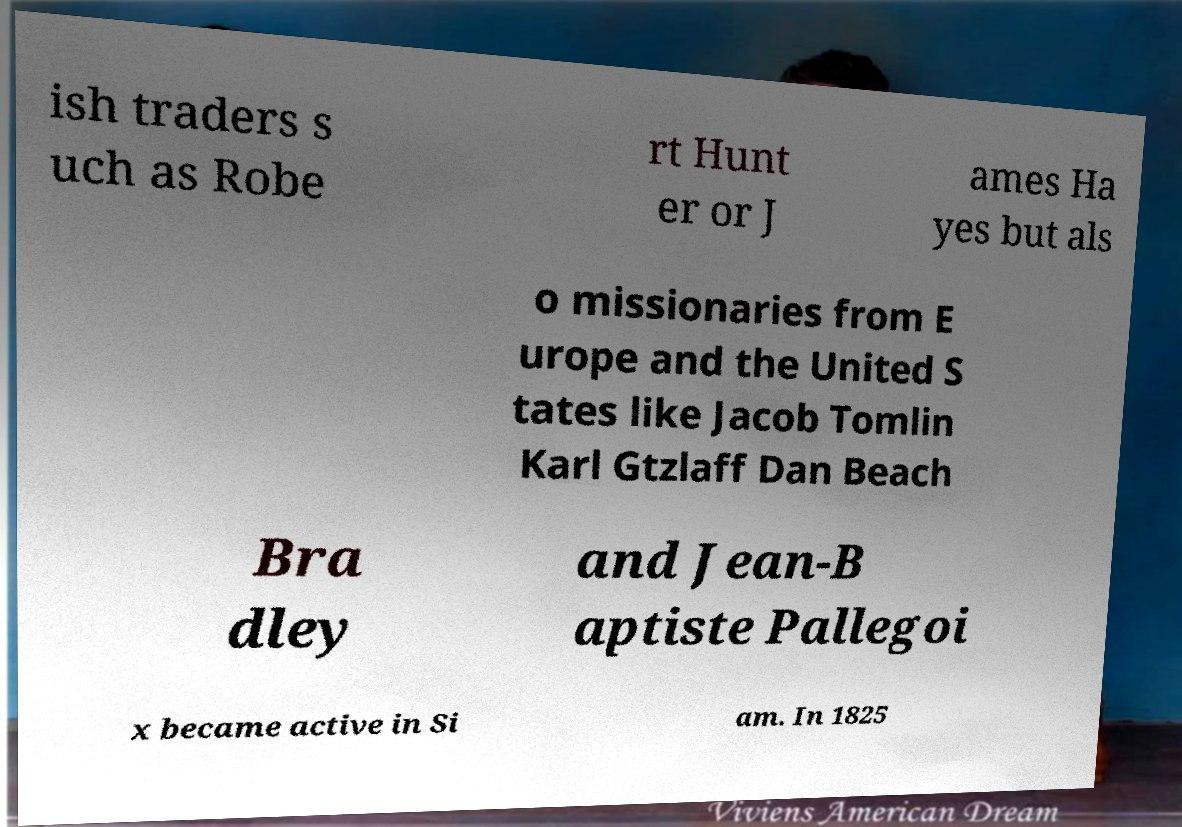For documentation purposes, I need the text within this image transcribed. Could you provide that? ish traders s uch as Robe rt Hunt er or J ames Ha yes but als o missionaries from E urope and the United S tates like Jacob Tomlin Karl Gtzlaff Dan Beach Bra dley and Jean-B aptiste Pallegoi x became active in Si am. In 1825 